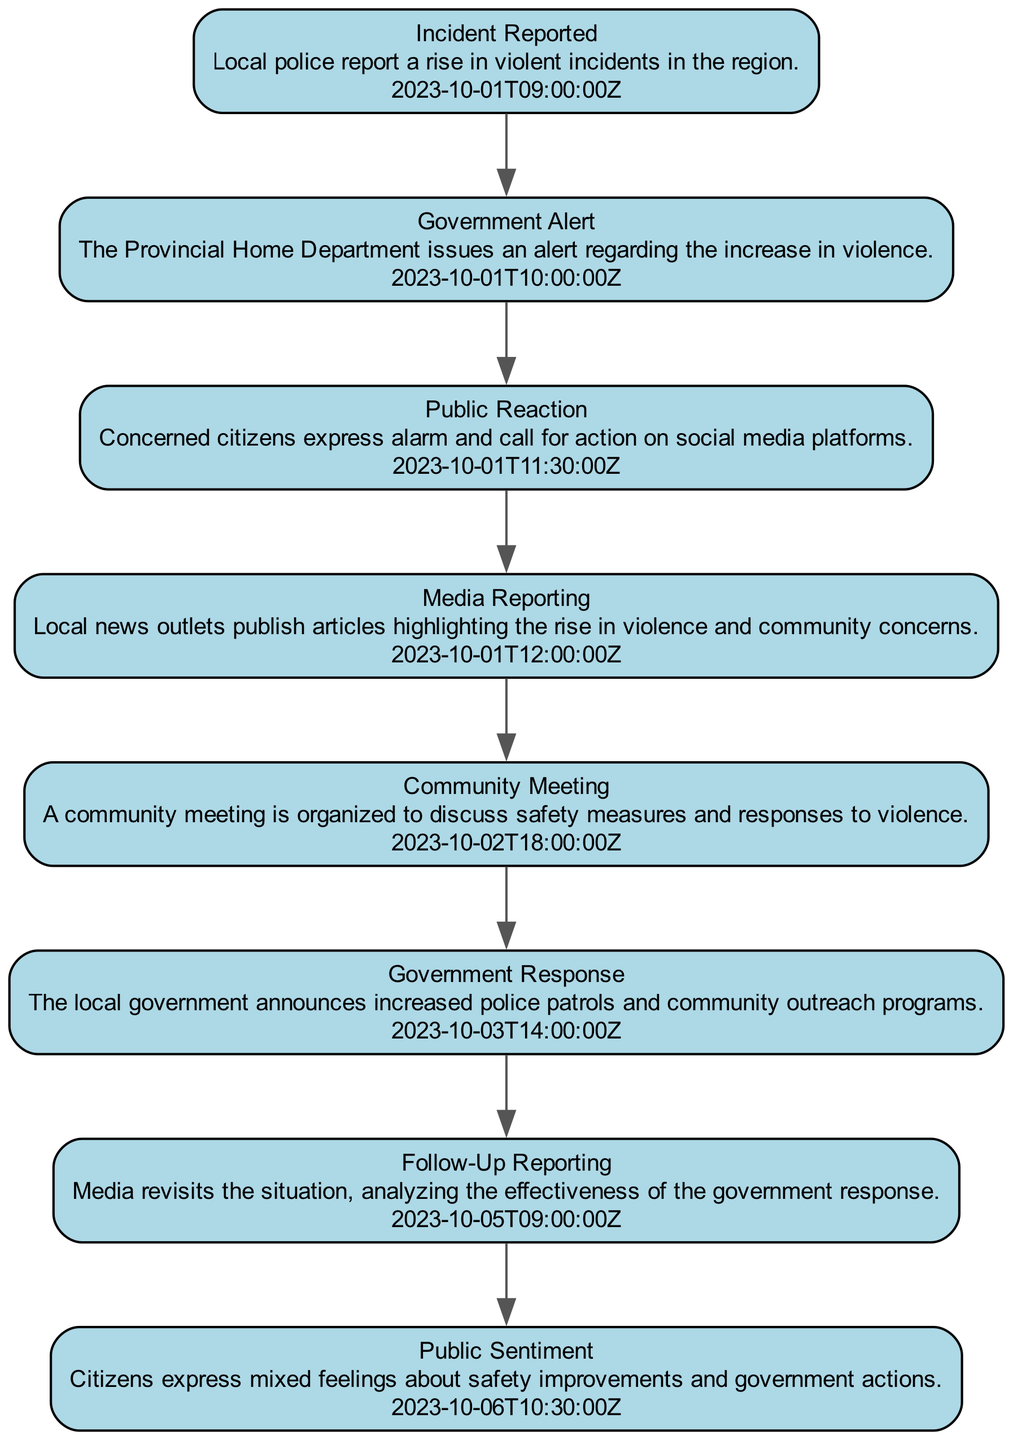What is the first event recorded in the timeline? The timeline begins with the "Incident Reported" event, which details a rise in violent incidents reported by local police. This is the earliest timestamp in the data provided.
Answer: Incident Reported How many total events are shown in the sequence diagram? By counting the individual events listed in the sequence diagram elements, we find a total of eight distinct events leading to the timeline's conclusion.
Answer: 8 What was the timestamp of the "Government Alert" event? The "Government Alert" event was reported at the timestamp "2023-10-01T10:00:00Z," which can be directly extracted from the event description in the timeline.
Answer: 2023-10-01T10:00:00Z Which event directly follows the "Public Reaction"? The "Media Reporting" event follows directly after "Public Reaction," as indicated by the ordering of events by their timestamps in the sequence diagram.
Answer: Media Reporting What is the public sentiment expressed after the "Government Response"? The citizens expressed "mixed feelings" about safety improvements and government actions, as highlighted in the timeline following the government’s response to the violence.
Answer: Mixed feelings What connection can be made between the "Community Meeting" and "Government Response" events? The "Community Meeting" occurred after the "Government Response," indicating that discussions about safety measures were organized in response to government actions aimed at addressing the violent situation. This highlights the community's need for communication after authorities acted.
Answer: Community concern How many days elapsed between the "Incident Reported" and the "Follow-Up Reporting"? The elapsed time from "Incident Reported" on October 1st to "Follow-Up Reporting" on October 5th spans four days, which can be calculated by simply counting the days between the two timestamps provided in the sequence.
Answer: 4 days Which event depicts citizen actions on social media? The "Public Reaction" event demonstrates citizen actions on social media, specifically where concerned individuals express alarm and call for governmental action regarding the rise in violence.
Answer: Public Reaction 